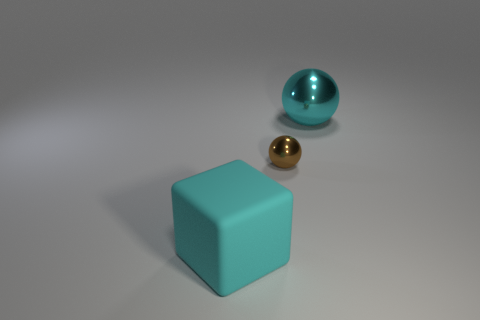What could be the possible uses for these objects in a practical scenario? In a practical setting, these objects could serve as models for a variety of purposes. The matte turquoise cube might be used as a paperweight or as a decorative element for a minimalist space. The shiny gold sphere could be a knob or handle for furniture, or perhaps an ornamental object. The glossy teal ball might find use as a sleek, modern element in interior design or as part of a visual display in a store window. 